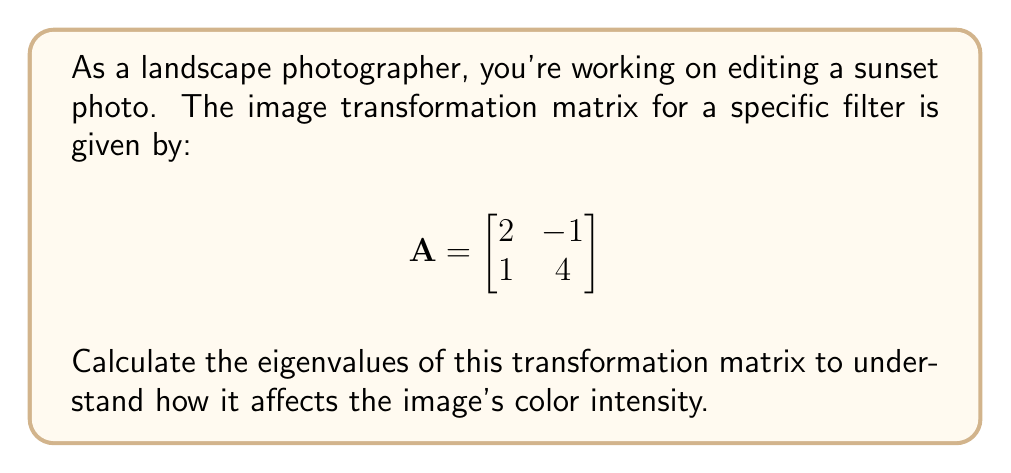Could you help me with this problem? To find the eigenvalues of matrix A, we follow these steps:

1) The characteristic equation is given by $\det(A - \lambda I) = 0$, where $\lambda$ represents the eigenvalues and I is the 2x2 identity matrix.

2) Expand the determinant:

   $$\det\begin{pmatrix}
   2-\lambda & -1 \\
   1 & 4-\lambda
   \end{pmatrix} = 0$$

3) Calculate the determinant:

   $$(2-\lambda)(4-\lambda) - (-1)(1) = 0$$

4) Simplify:

   $$8 - 2\lambda - 4\lambda + \lambda^2 + 1 = 0$$
   $$\lambda^2 - 6\lambda + 9 = 0$$

5) This is a quadratic equation. We can solve it using the quadratic formula:

   $$\lambda = \frac{-b \pm \sqrt{b^2 - 4ac}}{2a}$$

   Where $a=1$, $b=-6$, and $c=9$

6) Substitute these values:

   $$\lambda = \frac{6 \pm \sqrt{36 - 36}}{2} = \frac{6 \pm 0}{2} = 3$$

Therefore, both eigenvalues are equal to 3.
Answer: $\lambda_1 = \lambda_2 = 3$ 